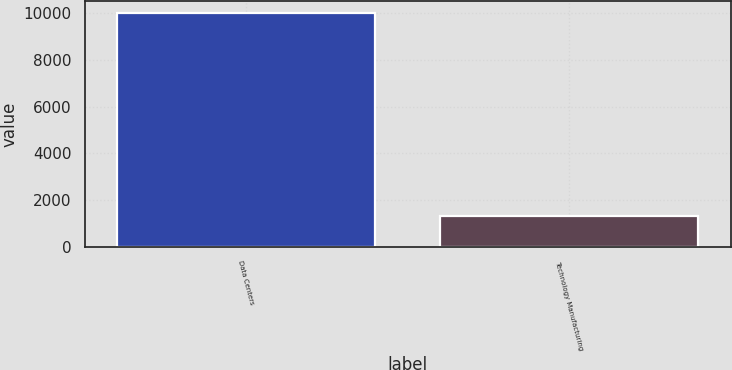Convert chart. <chart><loc_0><loc_0><loc_500><loc_500><bar_chart><fcel>Data Centers<fcel>Technology Manufacturing<nl><fcel>10014<fcel>1321<nl></chart> 